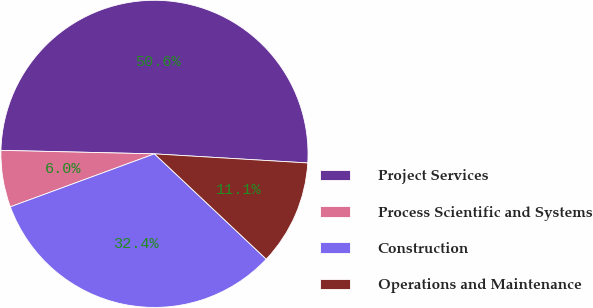Convert chart to OTSL. <chart><loc_0><loc_0><loc_500><loc_500><pie_chart><fcel>Project Services<fcel>Process Scientific and Systems<fcel>Construction<fcel>Operations and Maintenance<nl><fcel>50.58%<fcel>5.97%<fcel>32.37%<fcel>11.08%<nl></chart> 